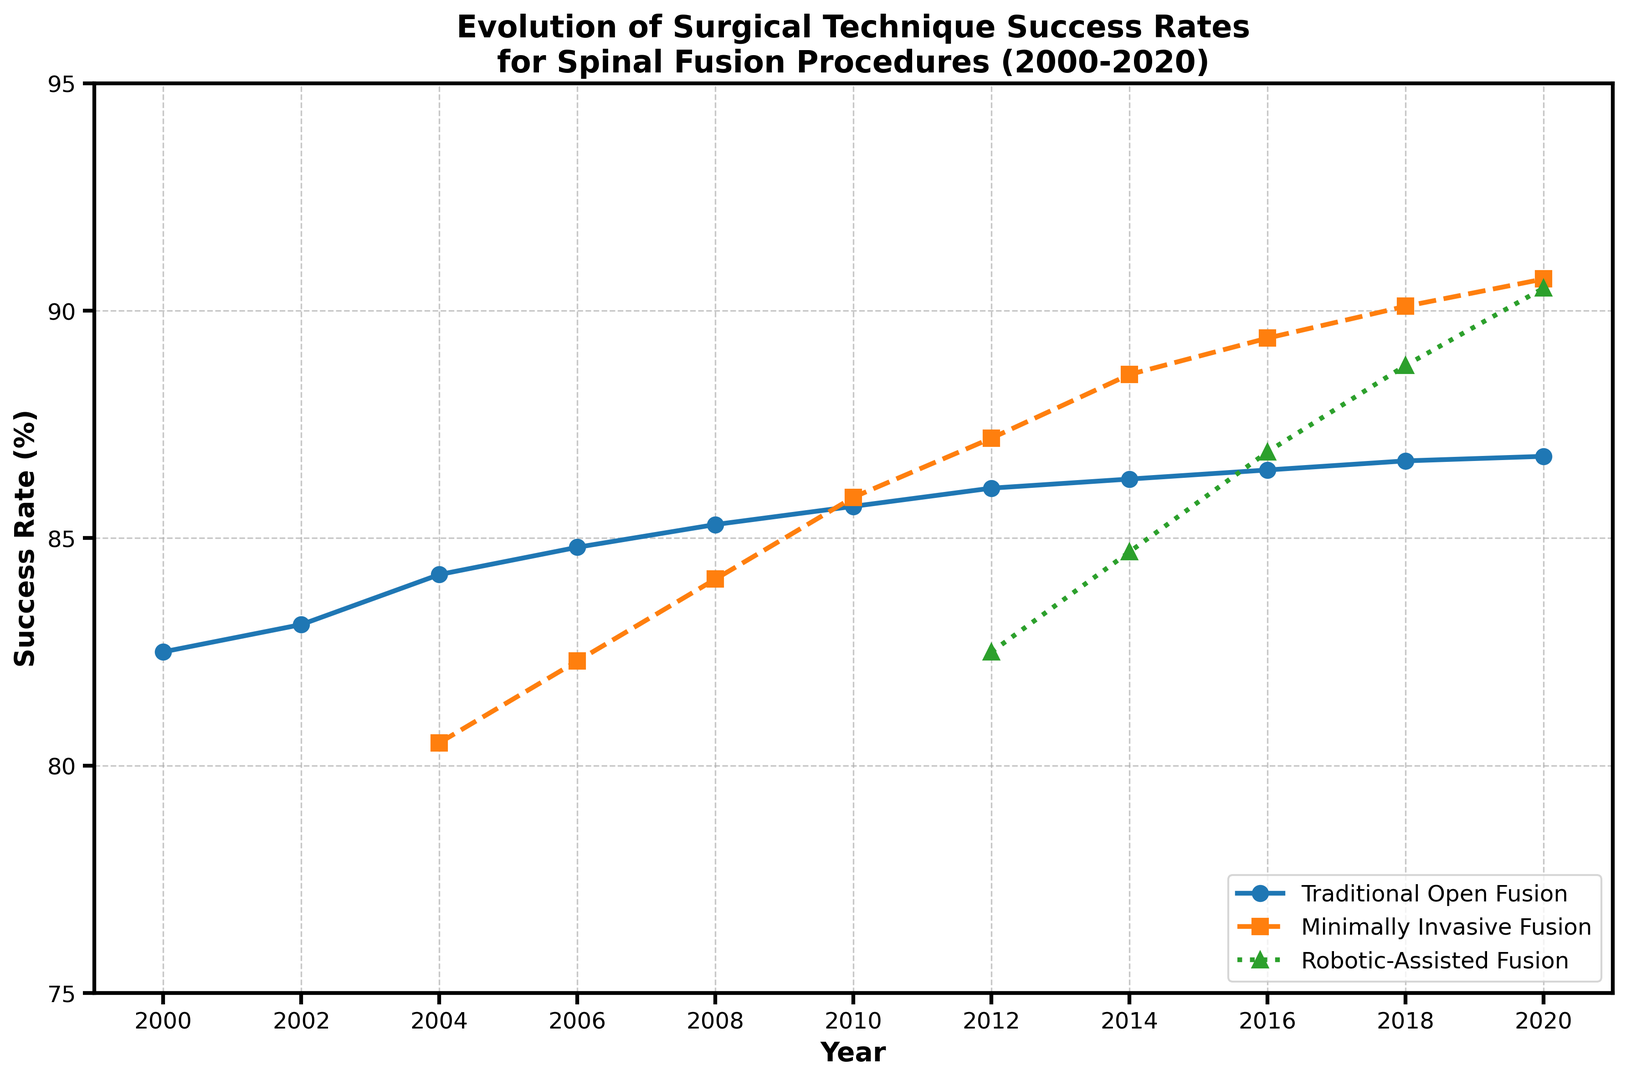Which surgical technique showed the highest success rate in 2020? To determine the highest success rate in 2020, look at the end of the three lines in the graph for that year. The success rates are Traditional Open Fusion: 86.8%, Minimally Invasive Fusion: 90.7%, Robotic-Assisted Fusion: 90.5%. The highest value is Minimally Invasive Fusion with 90.7%.
Answer: Minimally Invasive Fusion How much did the success rate for Traditional Open Fusion improve from 2000 to 2020? Subtract the success rate of Traditional Open Fusion in 2000 (82.5%) from the rate in 2020 (86.8%). The difference is 86.8% - 82.5% = 4.3%.
Answer: 4.3% What is the difference between the success rates of Minimally Invasive Fusion and Robotic-Assisted Fusion in 2014? Look at the success rates for both techniques in 2014. Minimally Invasive Fusion has a success rate of 88.6% while Robotic-Assisted Fusion has 84.7%. Subtract the lower value from the higher value: 88.6% - 84.7% = 3.9%.
Answer: 3.9% In which year did Minimally Invasive Fusion first surpass Traditional Open Fusion in success rate? Inspect where the Minimally Invasive Fusion line crosses above the Traditional Open Fusion line. This happens between 2008 and 2010. In 2010, Minimally Invasive Fusion (85.9%) is higher than Traditional Open Fusion (85.7%).
Answer: 2010 Which technique had the steepest increase in success rate between 2000 and 2010? To determine this, compare the total increase for each technique over 2000 to 2010. Traditional Open Fusion increased from 82.5% to 85.7% (3.2%), and Minimally Invasive Fusion started from its first point in 2004, increasing from 80.5% to 85.9% (5.4%). Minimally Invasive Fusion has the steepest increase.
Answer: Minimally Invasive Fusion How many years did it take for Robotic-Assisted Fusion to reach a 90% success rate after its introduction? Robotic-Assisted Fusion appears first in 2012 with a success rate of 82.5%. It reached 90.5% by 2020. The number of years taken is 2020 - 2012 = 8 years.
Answer: 8 years What was the average success rate of Minimally Invasive Fusion technique from 2004 to 2020? Sum the success rates of Minimally Invasive Fusion from 2004 (80.5%), 2006 (82.3%), 2008 (84.1%), 2010 (85.9%), 2012 (87.2%), 2014 (88.6%), 2016 (89.4%), 2018 (90.1%), and 2020 (90.7%), and then divide by the number of years (9). The total is 778.8, so the average is 778.8 / 9 ≈ 86.53%.
Answer: 86.53% Did any technique's success rate decrease in any year? To answer this, check if there is any point where the line graph drops for each technique. All lines for Traditional Open Fusion and Minimally Invasive Fusion either remain constant or increase. Robotic-Assisted Fusion shows a consistent increase, so no technique showed a decrease in success rate in any year.
Answer: No 